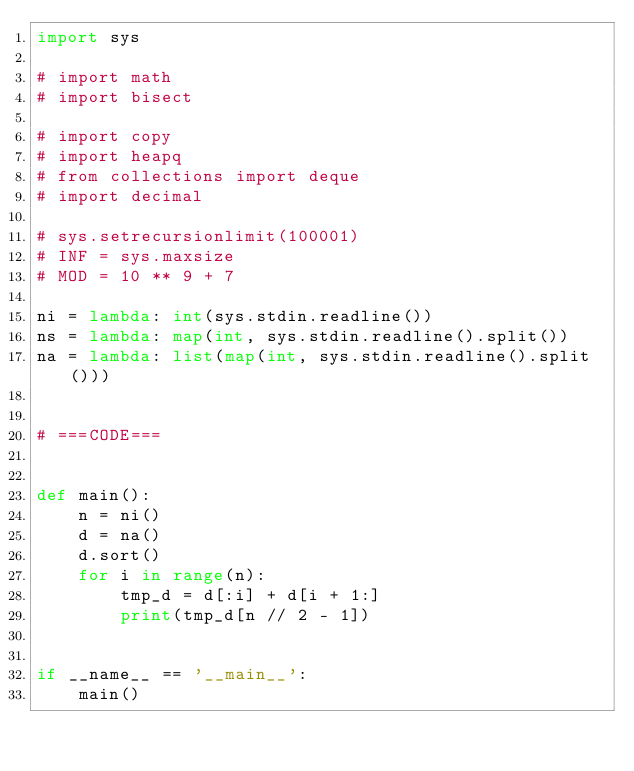<code> <loc_0><loc_0><loc_500><loc_500><_Python_>import sys

# import math
# import bisect

# import copy
# import heapq
# from collections import deque
# import decimal

# sys.setrecursionlimit(100001)
# INF = sys.maxsize
# MOD = 10 ** 9 + 7

ni = lambda: int(sys.stdin.readline())
ns = lambda: map(int, sys.stdin.readline().split())
na = lambda: list(map(int, sys.stdin.readline().split()))


# ===CODE===


def main():
    n = ni()
    d = na()
    d.sort()
    for i in range(n):
        tmp_d = d[:i] + d[i + 1:]
        print(tmp_d[n // 2 - 1])


if __name__ == '__main__':
    main()
</code> 